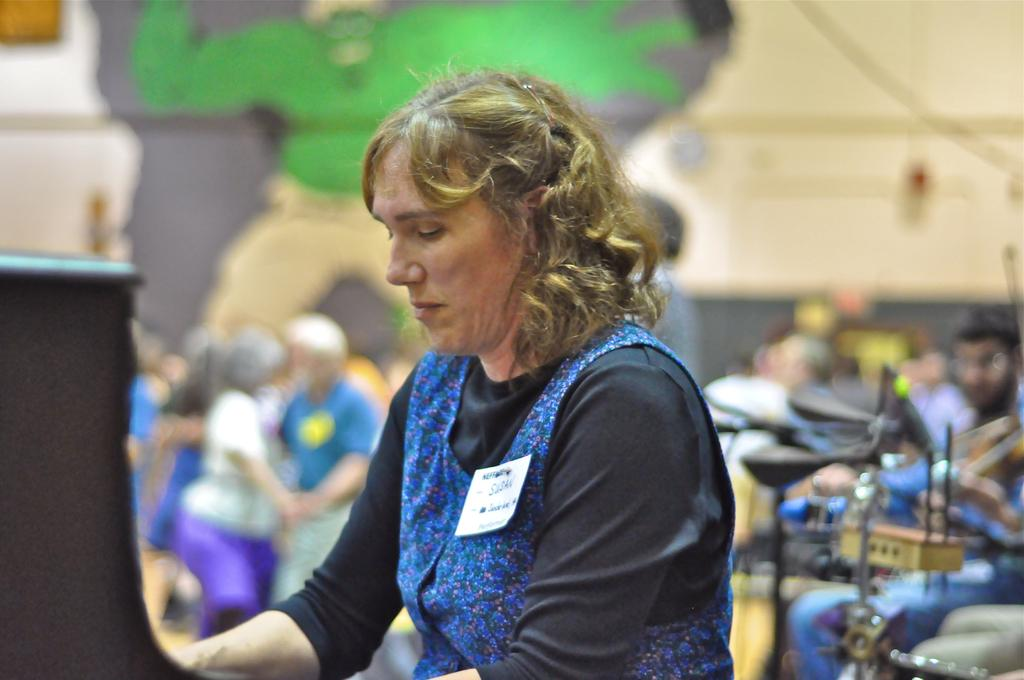Who is the main subject in the image? There is a lady in the image. What is the lady wearing? The lady is wearing a batch. Are there any other people visible in the image? Yes, there are other people visible behind the lady. What type of fear can be seen on the lady's tongue in the image? There is no mention of fear or a tongue in the image, and therefore no such emotion can be observed. 